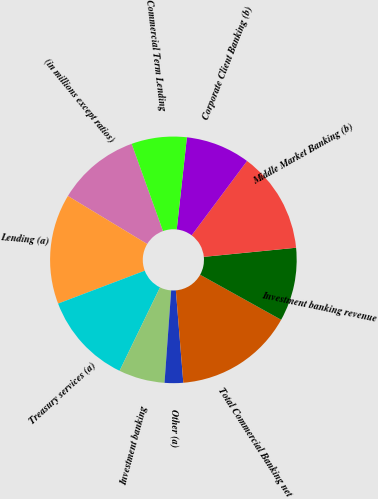Convert chart. <chart><loc_0><loc_0><loc_500><loc_500><pie_chart><fcel>(in millions except ratios)<fcel>Lending (a)<fcel>Treasury services (a)<fcel>Investment banking<fcel>Other (a)<fcel>Total Commercial Banking net<fcel>Investment banking revenue<fcel>Middle Market Banking (b)<fcel>Corporate Client Banking (b)<fcel>Commercial Term Lending<nl><fcel>10.84%<fcel>14.44%<fcel>12.04%<fcel>6.04%<fcel>2.43%<fcel>15.64%<fcel>9.64%<fcel>13.24%<fcel>8.44%<fcel>7.24%<nl></chart> 